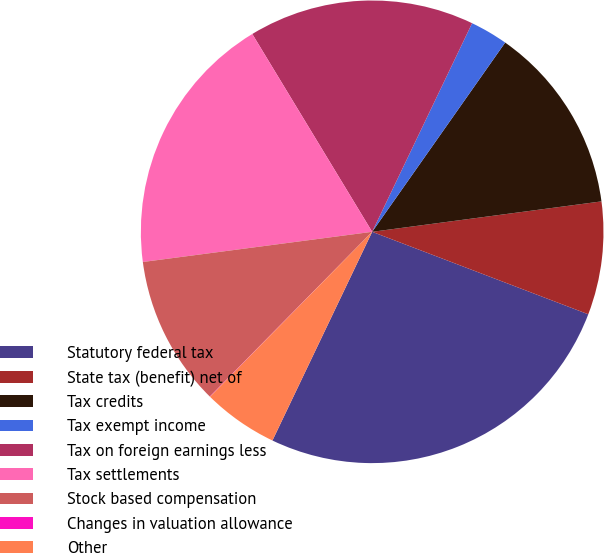<chart> <loc_0><loc_0><loc_500><loc_500><pie_chart><fcel>Statutory federal tax<fcel>State tax (benefit) net of<fcel>Tax credits<fcel>Tax exempt income<fcel>Tax on foreign earnings less<fcel>Tax settlements<fcel>Stock based compensation<fcel>Changes in valuation allowance<fcel>Other<nl><fcel>26.29%<fcel>7.9%<fcel>13.15%<fcel>2.64%<fcel>15.78%<fcel>18.41%<fcel>10.53%<fcel>0.02%<fcel>5.27%<nl></chart> 